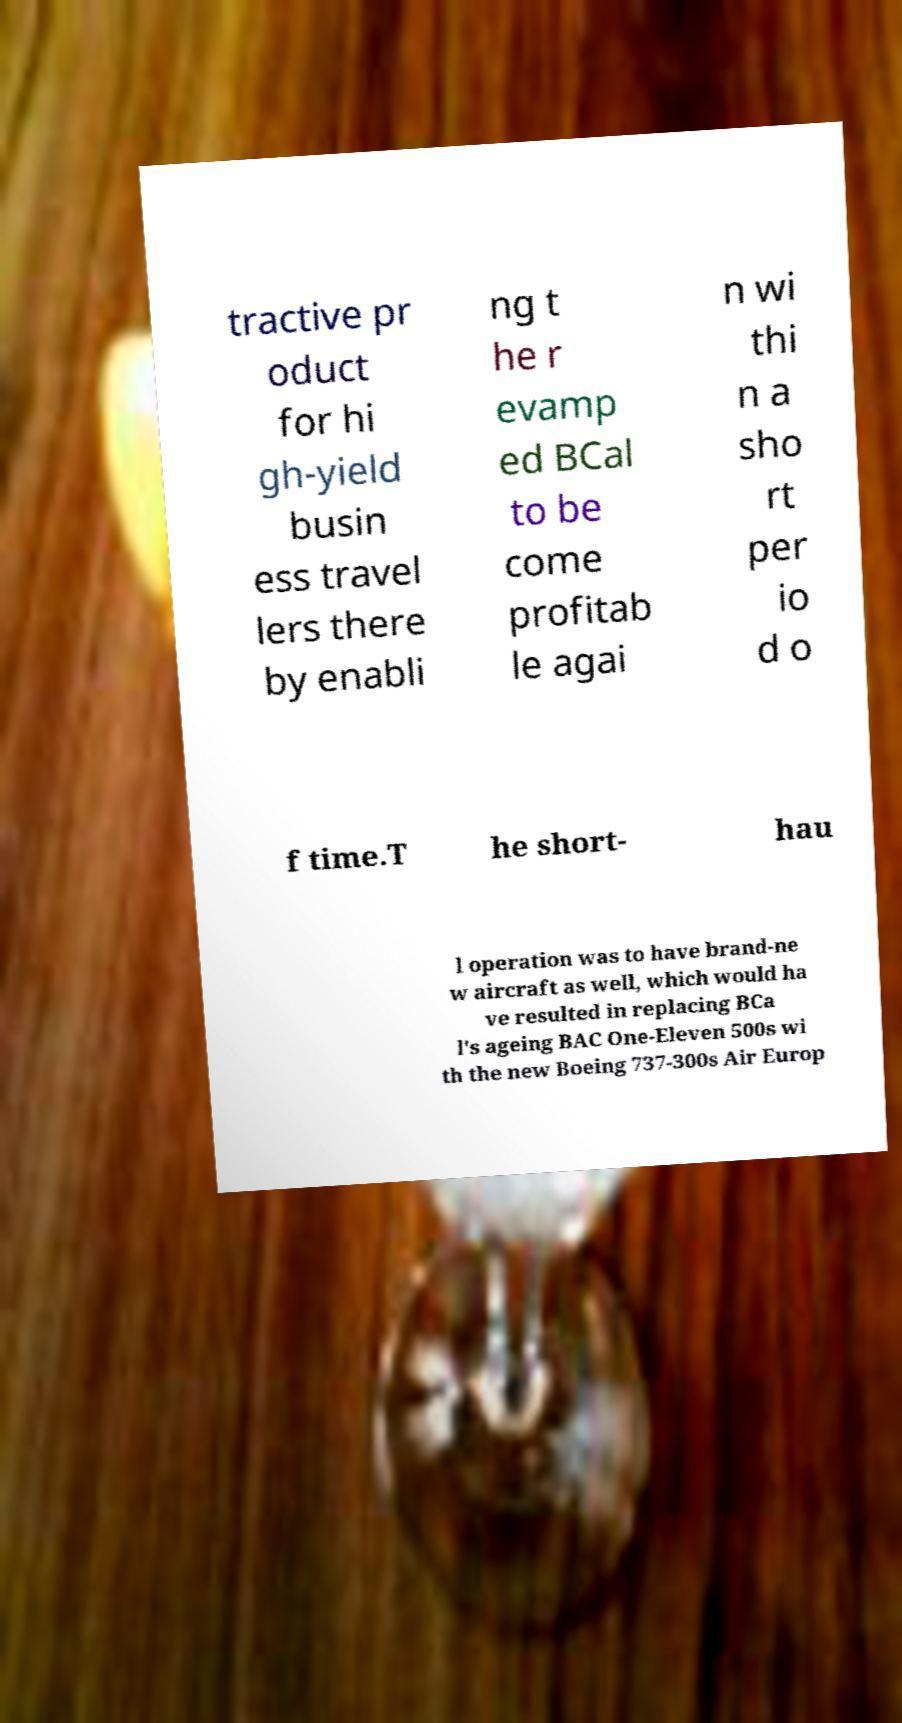Can you accurately transcribe the text from the provided image for me? tractive pr oduct for hi gh-yield busin ess travel lers there by enabli ng t he r evamp ed BCal to be come profitab le agai n wi thi n a sho rt per io d o f time.T he short- hau l operation was to have brand-ne w aircraft as well, which would ha ve resulted in replacing BCa l's ageing BAC One-Eleven 500s wi th the new Boeing 737-300s Air Europ 